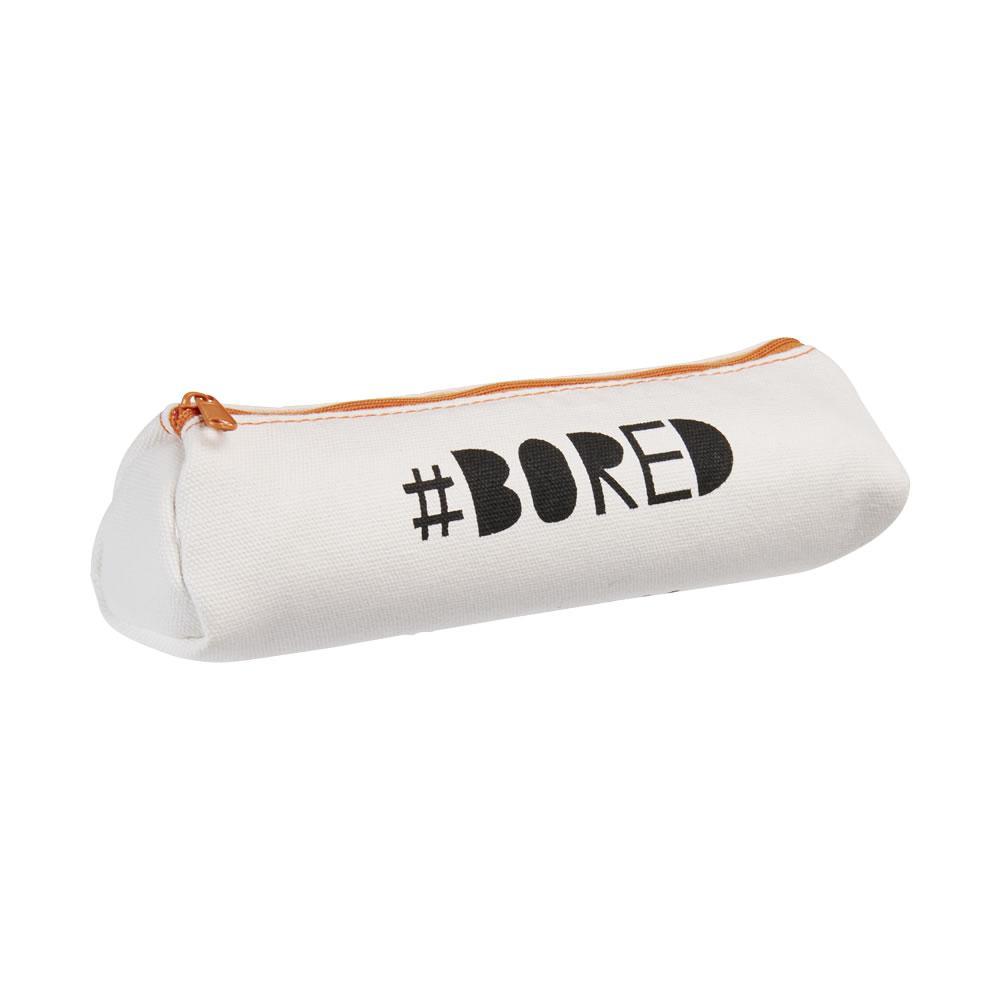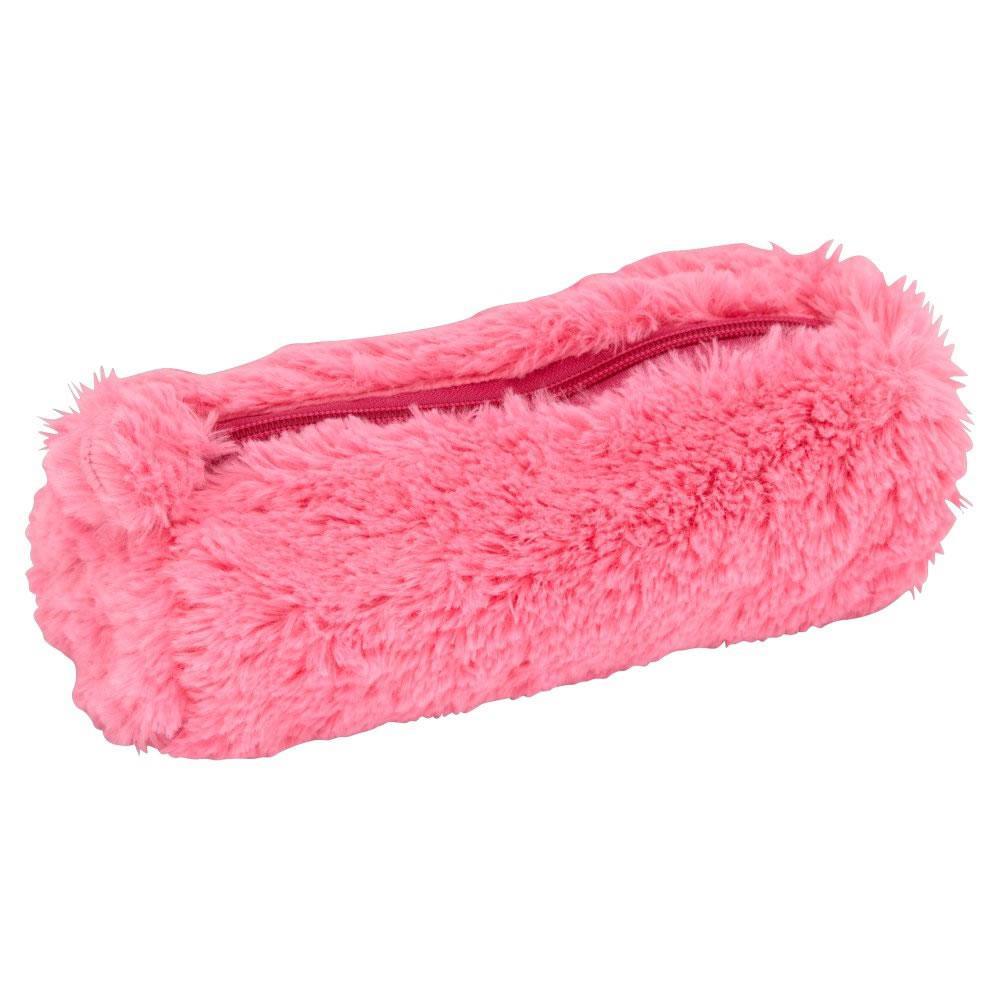The first image is the image on the left, the second image is the image on the right. For the images shown, is this caption "There are two pencil cases and they both have a similar long shape." true? Answer yes or no. Yes. 